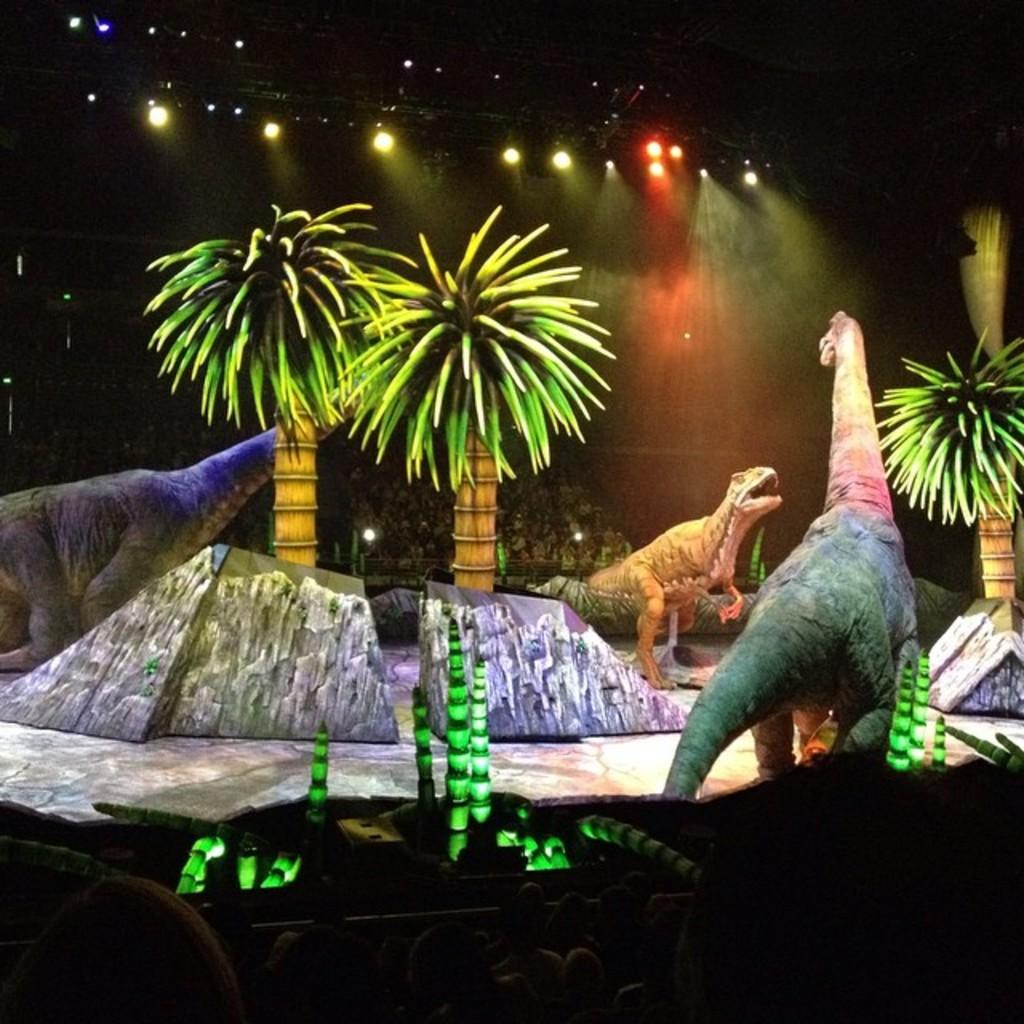What is depicted in the drawing in the image? The drawing contains a depiction of trees. What additional elements are included in the drawing? The drawing includes lights and animals. Can you describe the people in the background of the drawing? There are people present in the background of the drawing. What type of cracker is being used by the spy in the meeting in the image? There is no cracker, spy, or meeting present in the image; it features a drawing of trees with lights, animals, and people in the background. 